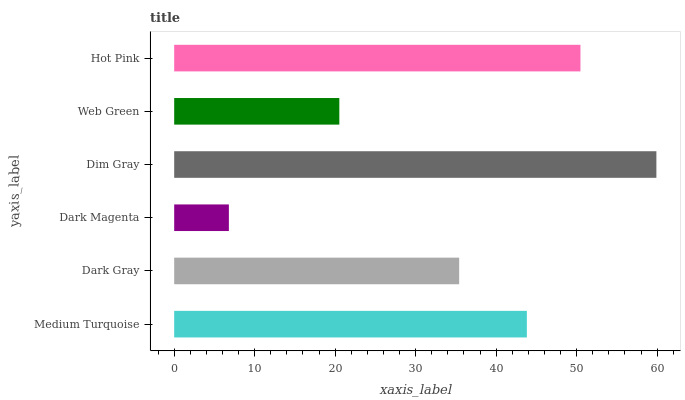Is Dark Magenta the minimum?
Answer yes or no. Yes. Is Dim Gray the maximum?
Answer yes or no. Yes. Is Dark Gray the minimum?
Answer yes or no. No. Is Dark Gray the maximum?
Answer yes or no. No. Is Medium Turquoise greater than Dark Gray?
Answer yes or no. Yes. Is Dark Gray less than Medium Turquoise?
Answer yes or no. Yes. Is Dark Gray greater than Medium Turquoise?
Answer yes or no. No. Is Medium Turquoise less than Dark Gray?
Answer yes or no. No. Is Medium Turquoise the high median?
Answer yes or no. Yes. Is Dark Gray the low median?
Answer yes or no. Yes. Is Web Green the high median?
Answer yes or no. No. Is Hot Pink the low median?
Answer yes or no. No. 